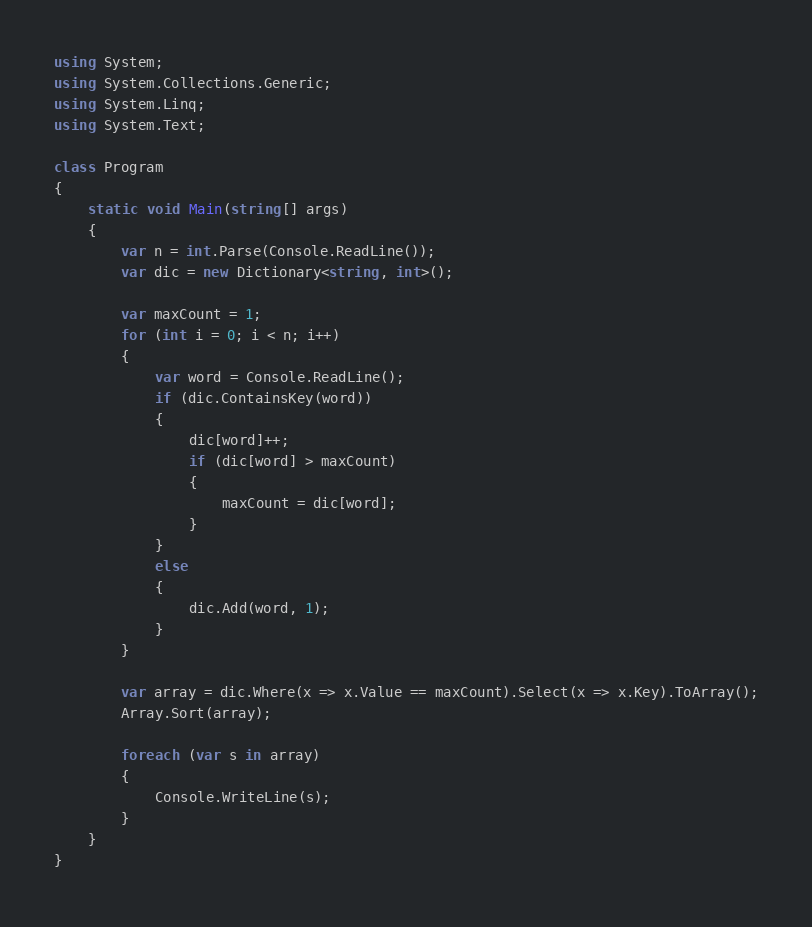<code> <loc_0><loc_0><loc_500><loc_500><_C#_>using System;
using System.Collections.Generic;
using System.Linq;
using System.Text;

class Program
{
    static void Main(string[] args)
    {
        var n = int.Parse(Console.ReadLine());
        var dic = new Dictionary<string, int>();

        var maxCount = 1;
        for (int i = 0; i < n; i++)
        {
            var word = Console.ReadLine();
            if (dic.ContainsKey(word))
            {
                dic[word]++;
                if (dic[word] > maxCount)
                {
                    maxCount = dic[word];
                }
            }
            else
            {
                dic.Add(word, 1);
            }
        }

        var array = dic.Where(x => x.Value == maxCount).Select(x => x.Key).ToArray();
        Array.Sort(array);

        foreach (var s in array)
        {
            Console.WriteLine(s);
        }
    }
}</code> 